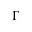Convert formula to latex. <formula><loc_0><loc_0><loc_500><loc_500>\Gamma</formula> 